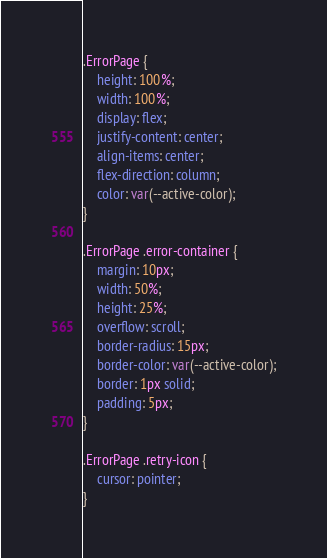<code> <loc_0><loc_0><loc_500><loc_500><_CSS_>.ErrorPage {
    height: 100%;
    width: 100%;
    display: flex;
    justify-content: center;
    align-items: center;
    flex-direction: column;
    color: var(--active-color);
}

.ErrorPage .error-container {
    margin: 10px;
    width: 50%;
    height: 25%;
    overflow: scroll;
    border-radius: 15px;
    border-color: var(--active-color);
    border: 1px solid;
    padding: 5px;
}

.ErrorPage .retry-icon {
    cursor: pointer;
}
</code> 